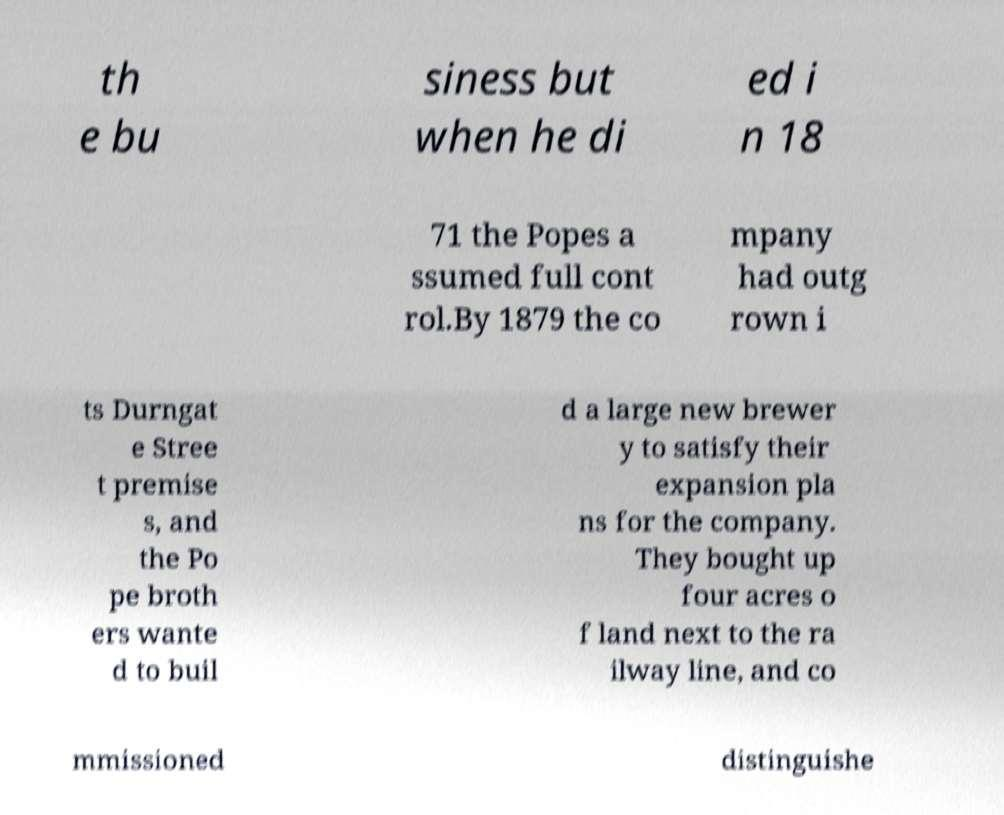Can you read and provide the text displayed in the image?This photo seems to have some interesting text. Can you extract and type it out for me? th e bu siness but when he di ed i n 18 71 the Popes a ssumed full cont rol.By 1879 the co mpany had outg rown i ts Durngat e Stree t premise s, and the Po pe broth ers wante d to buil d a large new brewer y to satisfy their expansion pla ns for the company. They bought up four acres o f land next to the ra ilway line, and co mmissioned distinguishe 